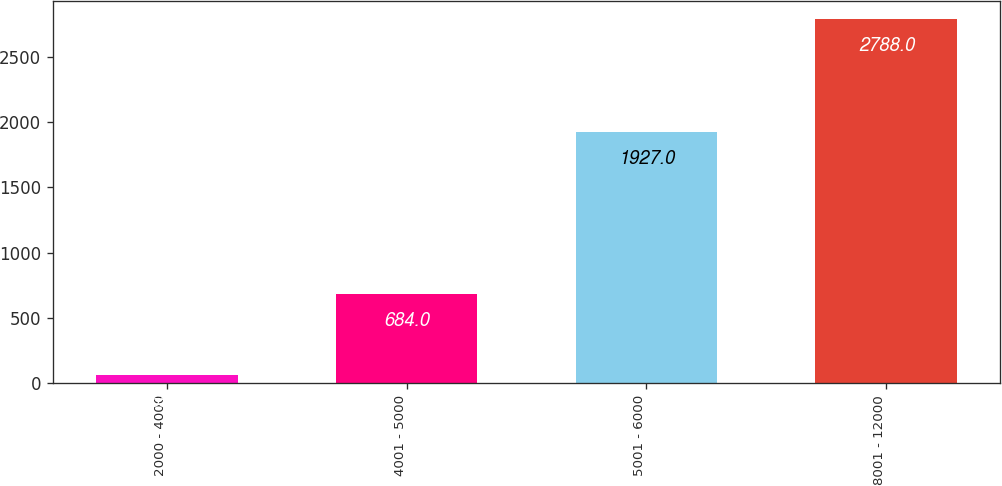Convert chart to OTSL. <chart><loc_0><loc_0><loc_500><loc_500><bar_chart><fcel>2000 - 4000<fcel>4001 - 5000<fcel>5001 - 6000<fcel>8001 - 12000<nl><fcel>65<fcel>684<fcel>1927<fcel>2788<nl></chart> 